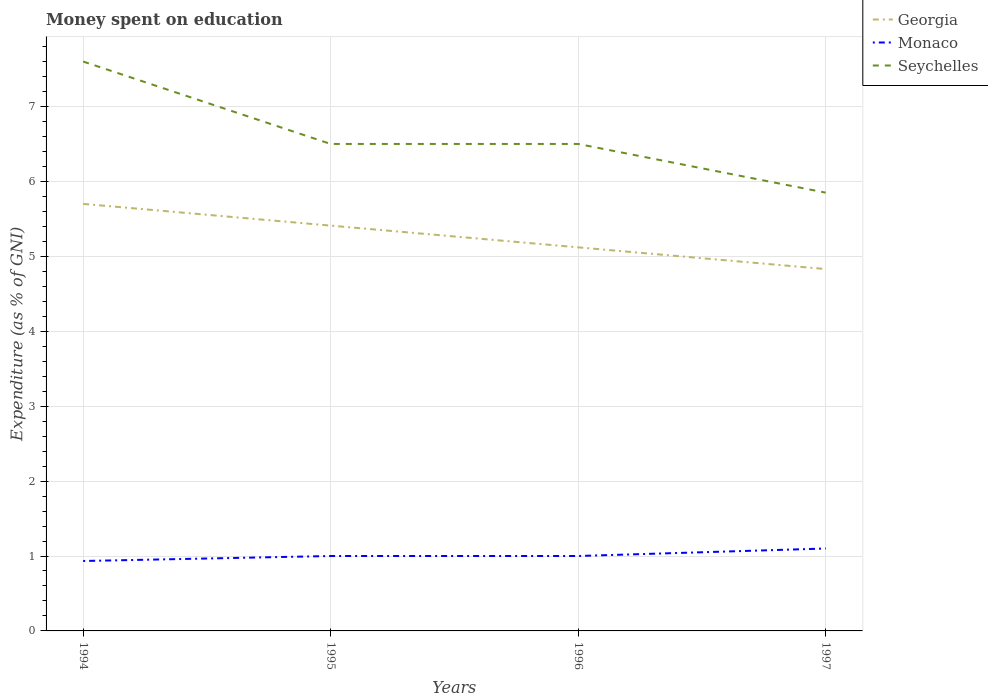How many different coloured lines are there?
Offer a very short reply. 3. Does the line corresponding to Seychelles intersect with the line corresponding to Monaco?
Your answer should be very brief. No. Across all years, what is the maximum amount of money spent on education in Seychelles?
Give a very brief answer. 5.85. What is the difference between the highest and the second highest amount of money spent on education in Monaco?
Your response must be concise. 0.17. How many lines are there?
Give a very brief answer. 3. Are the values on the major ticks of Y-axis written in scientific E-notation?
Provide a succinct answer. No. Does the graph contain any zero values?
Give a very brief answer. No. Where does the legend appear in the graph?
Offer a very short reply. Top right. How are the legend labels stacked?
Offer a very short reply. Vertical. What is the title of the graph?
Make the answer very short. Money spent on education. Does "Palau" appear as one of the legend labels in the graph?
Give a very brief answer. No. What is the label or title of the X-axis?
Make the answer very short. Years. What is the label or title of the Y-axis?
Offer a terse response. Expenditure (as % of GNI). What is the Expenditure (as % of GNI) of Georgia in 1994?
Make the answer very short. 5.7. What is the Expenditure (as % of GNI) in Monaco in 1994?
Provide a succinct answer. 0.93. What is the Expenditure (as % of GNI) in Seychelles in 1994?
Provide a short and direct response. 7.6. What is the Expenditure (as % of GNI) of Georgia in 1995?
Ensure brevity in your answer.  5.41. What is the Expenditure (as % of GNI) in Seychelles in 1995?
Offer a very short reply. 6.5. What is the Expenditure (as % of GNI) in Georgia in 1996?
Your response must be concise. 5.12. What is the Expenditure (as % of GNI) of Georgia in 1997?
Offer a very short reply. 4.83. What is the Expenditure (as % of GNI) in Monaco in 1997?
Your response must be concise. 1.1. What is the Expenditure (as % of GNI) of Seychelles in 1997?
Ensure brevity in your answer.  5.85. Across all years, what is the maximum Expenditure (as % of GNI) of Monaco?
Provide a short and direct response. 1.1. Across all years, what is the minimum Expenditure (as % of GNI) of Georgia?
Your answer should be very brief. 4.83. Across all years, what is the minimum Expenditure (as % of GNI) of Monaco?
Your answer should be very brief. 0.93. Across all years, what is the minimum Expenditure (as % of GNI) of Seychelles?
Keep it short and to the point. 5.85. What is the total Expenditure (as % of GNI) in Georgia in the graph?
Provide a short and direct response. 21.06. What is the total Expenditure (as % of GNI) in Monaco in the graph?
Make the answer very short. 4.03. What is the total Expenditure (as % of GNI) in Seychelles in the graph?
Ensure brevity in your answer.  26.45. What is the difference between the Expenditure (as % of GNI) in Georgia in 1994 and that in 1995?
Your answer should be very brief. 0.29. What is the difference between the Expenditure (as % of GNI) of Monaco in 1994 and that in 1995?
Offer a very short reply. -0.07. What is the difference between the Expenditure (as % of GNI) in Seychelles in 1994 and that in 1995?
Offer a very short reply. 1.1. What is the difference between the Expenditure (as % of GNI) of Georgia in 1994 and that in 1996?
Make the answer very short. 0.58. What is the difference between the Expenditure (as % of GNI) in Monaco in 1994 and that in 1996?
Make the answer very short. -0.07. What is the difference between the Expenditure (as % of GNI) of Seychelles in 1994 and that in 1996?
Keep it short and to the point. 1.1. What is the difference between the Expenditure (as % of GNI) in Georgia in 1994 and that in 1997?
Keep it short and to the point. 0.87. What is the difference between the Expenditure (as % of GNI) in Monaco in 1994 and that in 1997?
Make the answer very short. -0.17. What is the difference between the Expenditure (as % of GNI) in Seychelles in 1994 and that in 1997?
Provide a short and direct response. 1.75. What is the difference between the Expenditure (as % of GNI) in Georgia in 1995 and that in 1996?
Offer a terse response. 0.29. What is the difference between the Expenditure (as % of GNI) in Georgia in 1995 and that in 1997?
Your answer should be compact. 0.58. What is the difference between the Expenditure (as % of GNI) in Monaco in 1995 and that in 1997?
Provide a short and direct response. -0.1. What is the difference between the Expenditure (as % of GNI) in Seychelles in 1995 and that in 1997?
Your answer should be very brief. 0.65. What is the difference between the Expenditure (as % of GNI) in Georgia in 1996 and that in 1997?
Offer a very short reply. 0.29. What is the difference between the Expenditure (as % of GNI) of Seychelles in 1996 and that in 1997?
Offer a terse response. 0.65. What is the difference between the Expenditure (as % of GNI) in Georgia in 1994 and the Expenditure (as % of GNI) in Monaco in 1995?
Your response must be concise. 4.7. What is the difference between the Expenditure (as % of GNI) of Georgia in 1994 and the Expenditure (as % of GNI) of Seychelles in 1995?
Provide a succinct answer. -0.8. What is the difference between the Expenditure (as % of GNI) of Monaco in 1994 and the Expenditure (as % of GNI) of Seychelles in 1995?
Provide a succinct answer. -5.57. What is the difference between the Expenditure (as % of GNI) of Georgia in 1994 and the Expenditure (as % of GNI) of Monaco in 1996?
Offer a very short reply. 4.7. What is the difference between the Expenditure (as % of GNI) in Monaco in 1994 and the Expenditure (as % of GNI) in Seychelles in 1996?
Your answer should be very brief. -5.57. What is the difference between the Expenditure (as % of GNI) in Georgia in 1994 and the Expenditure (as % of GNI) in Monaco in 1997?
Your answer should be very brief. 4.6. What is the difference between the Expenditure (as % of GNI) of Georgia in 1994 and the Expenditure (as % of GNI) of Seychelles in 1997?
Offer a terse response. -0.15. What is the difference between the Expenditure (as % of GNI) in Monaco in 1994 and the Expenditure (as % of GNI) in Seychelles in 1997?
Provide a succinct answer. -4.92. What is the difference between the Expenditure (as % of GNI) of Georgia in 1995 and the Expenditure (as % of GNI) of Monaco in 1996?
Give a very brief answer. 4.41. What is the difference between the Expenditure (as % of GNI) of Georgia in 1995 and the Expenditure (as % of GNI) of Seychelles in 1996?
Offer a very short reply. -1.09. What is the difference between the Expenditure (as % of GNI) in Georgia in 1995 and the Expenditure (as % of GNI) in Monaco in 1997?
Your answer should be very brief. 4.31. What is the difference between the Expenditure (as % of GNI) in Georgia in 1995 and the Expenditure (as % of GNI) in Seychelles in 1997?
Your answer should be very brief. -0.44. What is the difference between the Expenditure (as % of GNI) in Monaco in 1995 and the Expenditure (as % of GNI) in Seychelles in 1997?
Your response must be concise. -4.85. What is the difference between the Expenditure (as % of GNI) of Georgia in 1996 and the Expenditure (as % of GNI) of Monaco in 1997?
Keep it short and to the point. 4.02. What is the difference between the Expenditure (as % of GNI) of Georgia in 1996 and the Expenditure (as % of GNI) of Seychelles in 1997?
Your answer should be very brief. -0.73. What is the difference between the Expenditure (as % of GNI) in Monaco in 1996 and the Expenditure (as % of GNI) in Seychelles in 1997?
Keep it short and to the point. -4.85. What is the average Expenditure (as % of GNI) of Georgia per year?
Offer a terse response. 5.26. What is the average Expenditure (as % of GNI) in Monaco per year?
Ensure brevity in your answer.  1.01. What is the average Expenditure (as % of GNI) of Seychelles per year?
Keep it short and to the point. 6.61. In the year 1994, what is the difference between the Expenditure (as % of GNI) in Georgia and Expenditure (as % of GNI) in Monaco?
Provide a short and direct response. 4.77. In the year 1994, what is the difference between the Expenditure (as % of GNI) of Monaco and Expenditure (as % of GNI) of Seychelles?
Provide a short and direct response. -6.67. In the year 1995, what is the difference between the Expenditure (as % of GNI) of Georgia and Expenditure (as % of GNI) of Monaco?
Your answer should be very brief. 4.41. In the year 1995, what is the difference between the Expenditure (as % of GNI) in Georgia and Expenditure (as % of GNI) in Seychelles?
Keep it short and to the point. -1.09. In the year 1995, what is the difference between the Expenditure (as % of GNI) in Monaco and Expenditure (as % of GNI) in Seychelles?
Provide a short and direct response. -5.5. In the year 1996, what is the difference between the Expenditure (as % of GNI) in Georgia and Expenditure (as % of GNI) in Monaco?
Offer a very short reply. 4.12. In the year 1996, what is the difference between the Expenditure (as % of GNI) in Georgia and Expenditure (as % of GNI) in Seychelles?
Your response must be concise. -1.38. In the year 1996, what is the difference between the Expenditure (as % of GNI) in Monaco and Expenditure (as % of GNI) in Seychelles?
Offer a very short reply. -5.5. In the year 1997, what is the difference between the Expenditure (as % of GNI) of Georgia and Expenditure (as % of GNI) of Monaco?
Offer a terse response. 3.73. In the year 1997, what is the difference between the Expenditure (as % of GNI) in Georgia and Expenditure (as % of GNI) in Seychelles?
Your answer should be compact. -1.02. In the year 1997, what is the difference between the Expenditure (as % of GNI) in Monaco and Expenditure (as % of GNI) in Seychelles?
Your answer should be very brief. -4.75. What is the ratio of the Expenditure (as % of GNI) of Georgia in 1994 to that in 1995?
Your answer should be very brief. 1.05. What is the ratio of the Expenditure (as % of GNI) in Seychelles in 1994 to that in 1995?
Give a very brief answer. 1.17. What is the ratio of the Expenditure (as % of GNI) of Georgia in 1994 to that in 1996?
Offer a very short reply. 1.11. What is the ratio of the Expenditure (as % of GNI) in Monaco in 1994 to that in 1996?
Ensure brevity in your answer.  0.93. What is the ratio of the Expenditure (as % of GNI) of Seychelles in 1994 to that in 1996?
Make the answer very short. 1.17. What is the ratio of the Expenditure (as % of GNI) in Georgia in 1994 to that in 1997?
Your response must be concise. 1.18. What is the ratio of the Expenditure (as % of GNI) of Monaco in 1994 to that in 1997?
Offer a terse response. 0.85. What is the ratio of the Expenditure (as % of GNI) in Seychelles in 1994 to that in 1997?
Ensure brevity in your answer.  1.3. What is the ratio of the Expenditure (as % of GNI) of Georgia in 1995 to that in 1996?
Ensure brevity in your answer.  1.06. What is the ratio of the Expenditure (as % of GNI) of Georgia in 1995 to that in 1997?
Your response must be concise. 1.12. What is the ratio of the Expenditure (as % of GNI) of Seychelles in 1995 to that in 1997?
Give a very brief answer. 1.11. What is the ratio of the Expenditure (as % of GNI) in Georgia in 1996 to that in 1997?
Give a very brief answer. 1.06. What is the ratio of the Expenditure (as % of GNI) of Seychelles in 1996 to that in 1997?
Provide a succinct answer. 1.11. What is the difference between the highest and the second highest Expenditure (as % of GNI) of Georgia?
Your answer should be compact. 0.29. What is the difference between the highest and the second highest Expenditure (as % of GNI) of Monaco?
Offer a very short reply. 0.1. What is the difference between the highest and the second highest Expenditure (as % of GNI) in Seychelles?
Ensure brevity in your answer.  1.1. What is the difference between the highest and the lowest Expenditure (as % of GNI) in Georgia?
Provide a short and direct response. 0.87. 